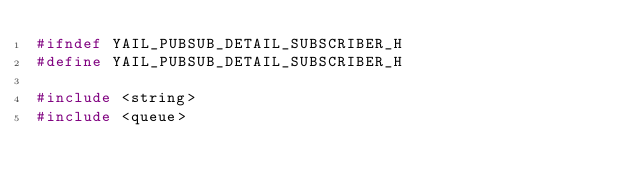<code> <loc_0><loc_0><loc_500><loc_500><_C_>#ifndef YAIL_PUBSUB_DETAIL_SUBSCRIBER_H
#define YAIL_PUBSUB_DETAIL_SUBSCRIBER_H

#include <string>
#include <queue></code> 